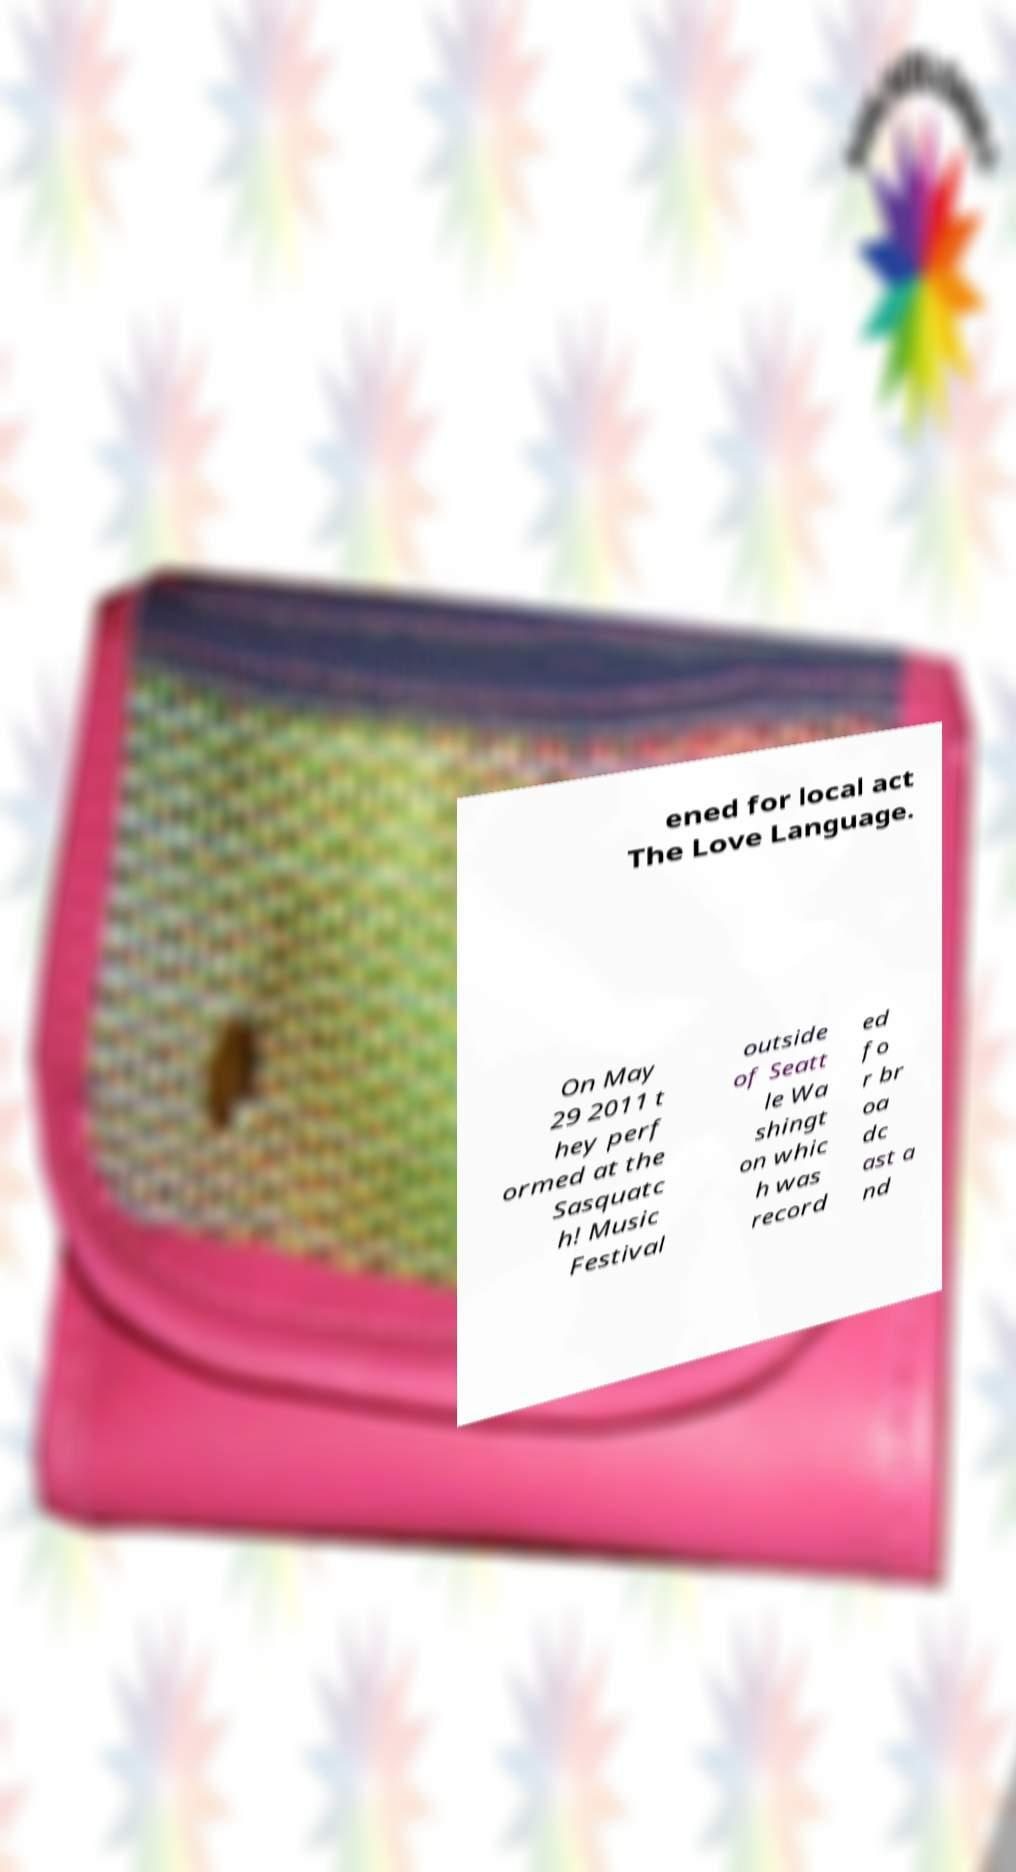Could you assist in decoding the text presented in this image and type it out clearly? ened for local act The Love Language. On May 29 2011 t hey perf ormed at the Sasquatc h! Music Festival outside of Seatt le Wa shingt on whic h was record ed fo r br oa dc ast a nd 